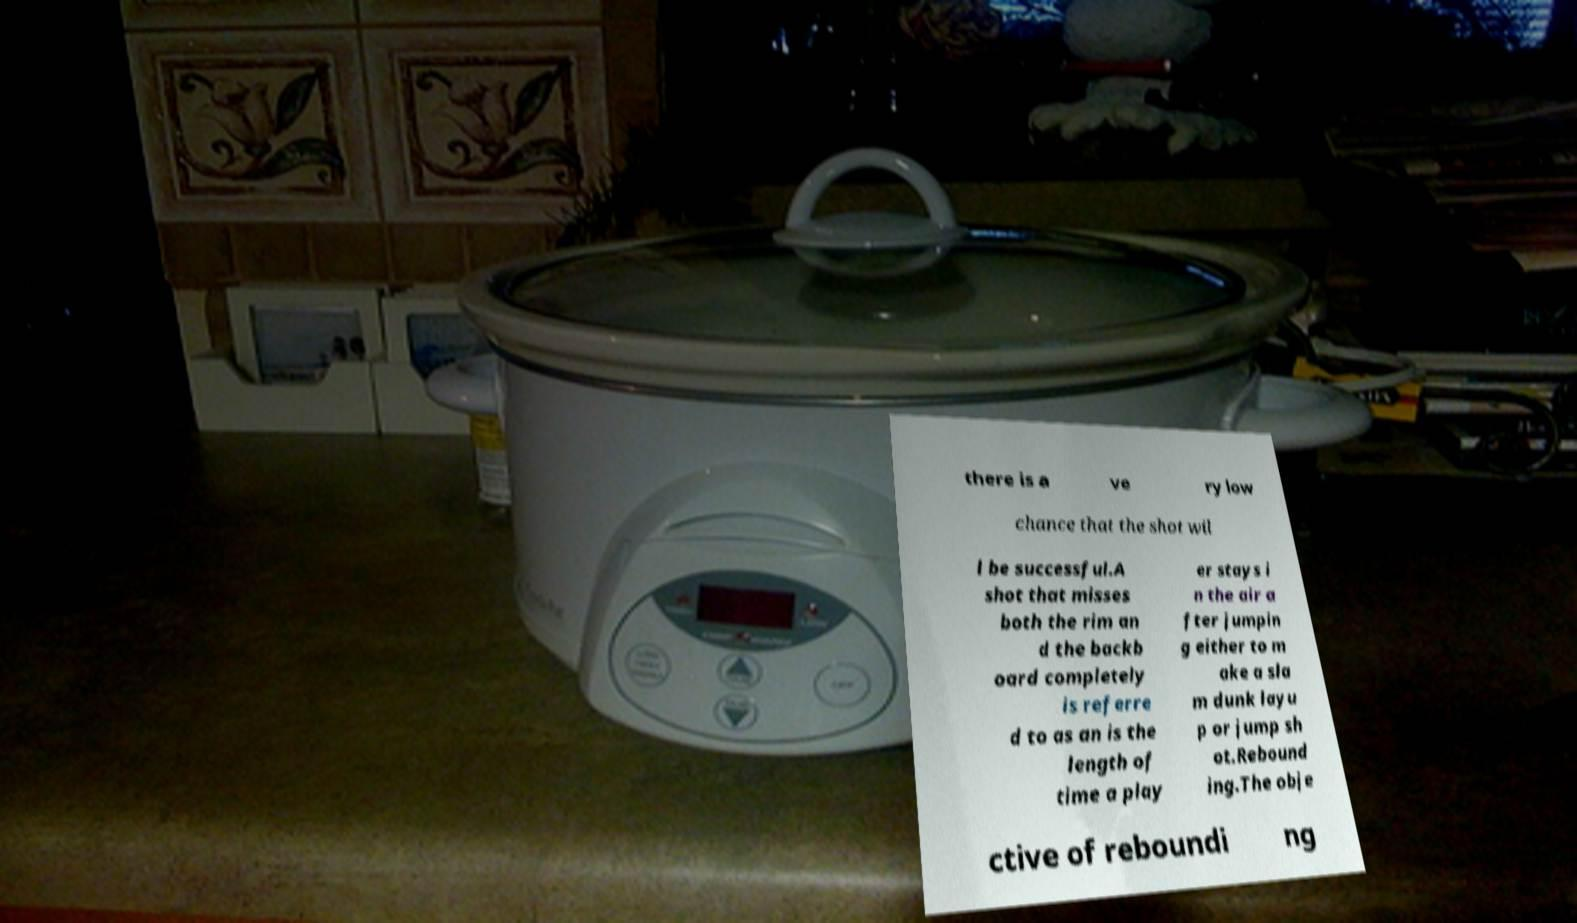Could you extract and type out the text from this image? there is a ve ry low chance that the shot wil l be successful.A shot that misses both the rim an d the backb oard completely is referre d to as an is the length of time a play er stays i n the air a fter jumpin g either to m ake a sla m dunk layu p or jump sh ot.Rebound ing.The obje ctive of reboundi ng 